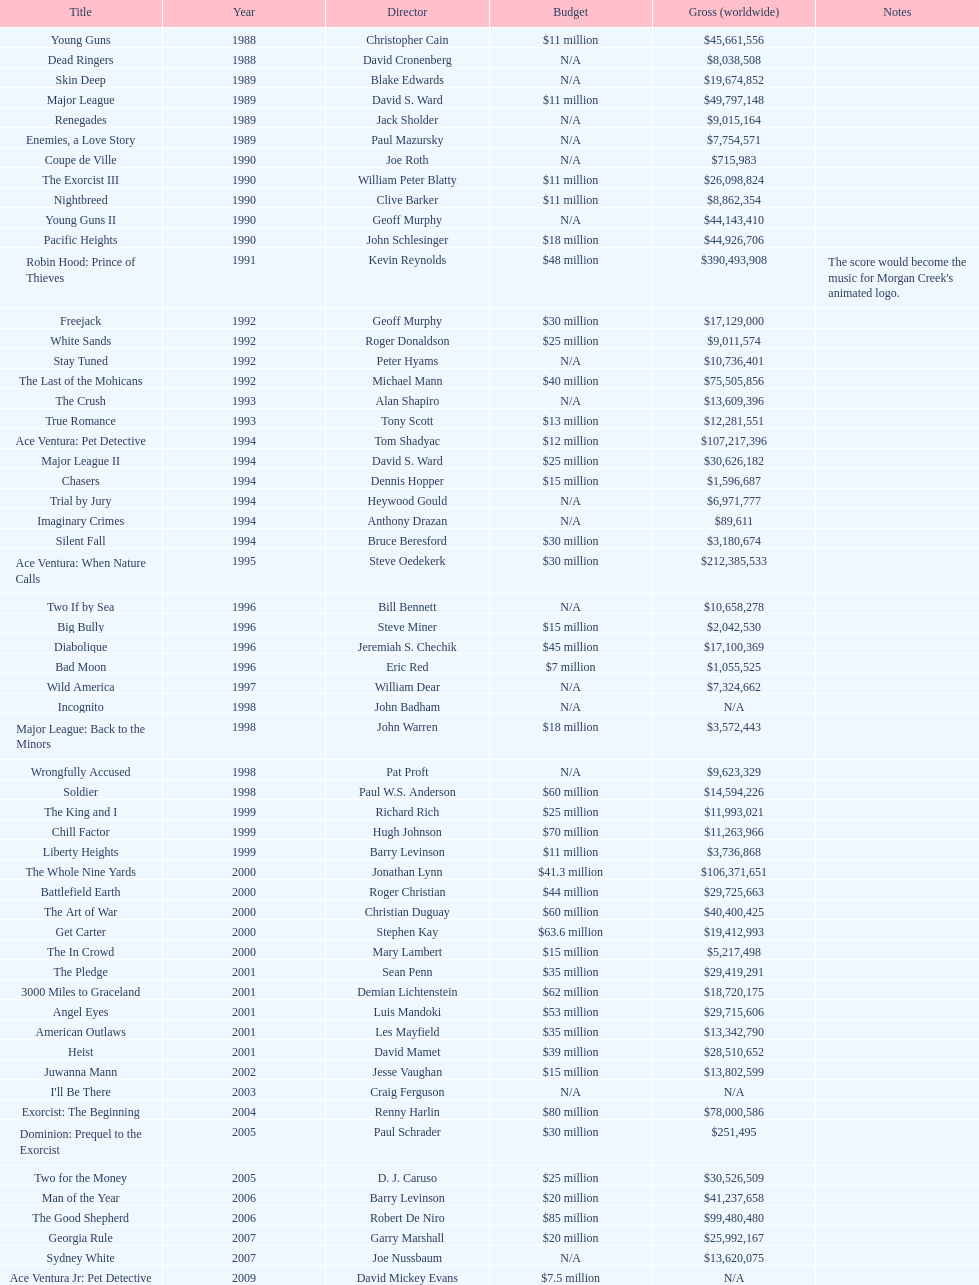Did true romance generate more or less income than diabolique? Less. Could you help me parse every detail presented in this table? {'header': ['Title', 'Year', 'Director', 'Budget', 'Gross (worldwide)', 'Notes'], 'rows': [['Young Guns', '1988', 'Christopher Cain', '$11 million', '$45,661,556', ''], ['Dead Ringers', '1988', 'David Cronenberg', 'N/A', '$8,038,508', ''], ['Skin Deep', '1989', 'Blake Edwards', 'N/A', '$19,674,852', ''], ['Major League', '1989', 'David S. Ward', '$11 million', '$49,797,148', ''], ['Renegades', '1989', 'Jack Sholder', 'N/A', '$9,015,164', ''], ['Enemies, a Love Story', '1989', 'Paul Mazursky', 'N/A', '$7,754,571', ''], ['Coupe de Ville', '1990', 'Joe Roth', 'N/A', '$715,983', ''], ['The Exorcist III', '1990', 'William Peter Blatty', '$11 million', '$26,098,824', ''], ['Nightbreed', '1990', 'Clive Barker', '$11 million', '$8,862,354', ''], ['Young Guns II', '1990', 'Geoff Murphy', 'N/A', '$44,143,410', ''], ['Pacific Heights', '1990', 'John Schlesinger', '$18 million', '$44,926,706', ''], ['Robin Hood: Prince of Thieves', '1991', 'Kevin Reynolds', '$48 million', '$390,493,908', "The score would become the music for Morgan Creek's animated logo."], ['Freejack', '1992', 'Geoff Murphy', '$30 million', '$17,129,000', ''], ['White Sands', '1992', 'Roger Donaldson', '$25 million', '$9,011,574', ''], ['Stay Tuned', '1992', 'Peter Hyams', 'N/A', '$10,736,401', ''], ['The Last of the Mohicans', '1992', 'Michael Mann', '$40 million', '$75,505,856', ''], ['The Crush', '1993', 'Alan Shapiro', 'N/A', '$13,609,396', ''], ['True Romance', '1993', 'Tony Scott', '$13 million', '$12,281,551', ''], ['Ace Ventura: Pet Detective', '1994', 'Tom Shadyac', '$12 million', '$107,217,396', ''], ['Major League II', '1994', 'David S. Ward', '$25 million', '$30,626,182', ''], ['Chasers', '1994', 'Dennis Hopper', '$15 million', '$1,596,687', ''], ['Trial by Jury', '1994', 'Heywood Gould', 'N/A', '$6,971,777', ''], ['Imaginary Crimes', '1994', 'Anthony Drazan', 'N/A', '$89,611', ''], ['Silent Fall', '1994', 'Bruce Beresford', '$30 million', '$3,180,674', ''], ['Ace Ventura: When Nature Calls', '1995', 'Steve Oedekerk', '$30 million', '$212,385,533', ''], ['Two If by Sea', '1996', 'Bill Bennett', 'N/A', '$10,658,278', ''], ['Big Bully', '1996', 'Steve Miner', '$15 million', '$2,042,530', ''], ['Diabolique', '1996', 'Jeremiah S. Chechik', '$45 million', '$17,100,369', ''], ['Bad Moon', '1996', 'Eric Red', '$7 million', '$1,055,525', ''], ['Wild America', '1997', 'William Dear', 'N/A', '$7,324,662', ''], ['Incognito', '1998', 'John Badham', 'N/A', 'N/A', ''], ['Major League: Back to the Minors', '1998', 'John Warren', '$18 million', '$3,572,443', ''], ['Wrongfully Accused', '1998', 'Pat Proft', 'N/A', '$9,623,329', ''], ['Soldier', '1998', 'Paul W.S. Anderson', '$60 million', '$14,594,226', ''], ['The King and I', '1999', 'Richard Rich', '$25 million', '$11,993,021', ''], ['Chill Factor', '1999', 'Hugh Johnson', '$70 million', '$11,263,966', ''], ['Liberty Heights', '1999', 'Barry Levinson', '$11 million', '$3,736,868', ''], ['The Whole Nine Yards', '2000', 'Jonathan Lynn', '$41.3 million', '$106,371,651', ''], ['Battlefield Earth', '2000', 'Roger Christian', '$44 million', '$29,725,663', ''], ['The Art of War', '2000', 'Christian Duguay', '$60 million', '$40,400,425', ''], ['Get Carter', '2000', 'Stephen Kay', '$63.6 million', '$19,412,993', ''], ['The In Crowd', '2000', 'Mary Lambert', '$15 million', '$5,217,498', ''], ['The Pledge', '2001', 'Sean Penn', '$35 million', '$29,419,291', ''], ['3000 Miles to Graceland', '2001', 'Demian Lichtenstein', '$62 million', '$18,720,175', ''], ['Angel Eyes', '2001', 'Luis Mandoki', '$53 million', '$29,715,606', ''], ['American Outlaws', '2001', 'Les Mayfield', '$35 million', '$13,342,790', ''], ['Heist', '2001', 'David Mamet', '$39 million', '$28,510,652', ''], ['Juwanna Mann', '2002', 'Jesse Vaughan', '$15 million', '$13,802,599', ''], ["I'll Be There", '2003', 'Craig Ferguson', 'N/A', 'N/A', ''], ['Exorcist: The Beginning', '2004', 'Renny Harlin', '$80 million', '$78,000,586', ''], ['Dominion: Prequel to the Exorcist', '2005', 'Paul Schrader', '$30 million', '$251,495', ''], ['Two for the Money', '2005', 'D. J. Caruso', '$25 million', '$30,526,509', ''], ['Man of the Year', '2006', 'Barry Levinson', '$20 million', '$41,237,658', ''], ['The Good Shepherd', '2006', 'Robert De Niro', '$85 million', '$99,480,480', ''], ['Georgia Rule', '2007', 'Garry Marshall', '$20 million', '$25,992,167', ''], ['Sydney White', '2007', 'Joe Nussbaum', 'N/A', '$13,620,075', ''], ['Ace Ventura Jr: Pet Detective', '2009', 'David Mickey Evans', '$7.5 million', 'N/A', ''], ['Dream House', '2011', 'Jim Sheridan', '$50 million', '$38,502,340', ''], ['The Thing', '2011', 'Matthijs van Heijningen Jr.', '$38 million', '$27,428,670', ''], ['Tupac', '2014', 'Antoine Fuqua', '$45 million', '', '']]} 